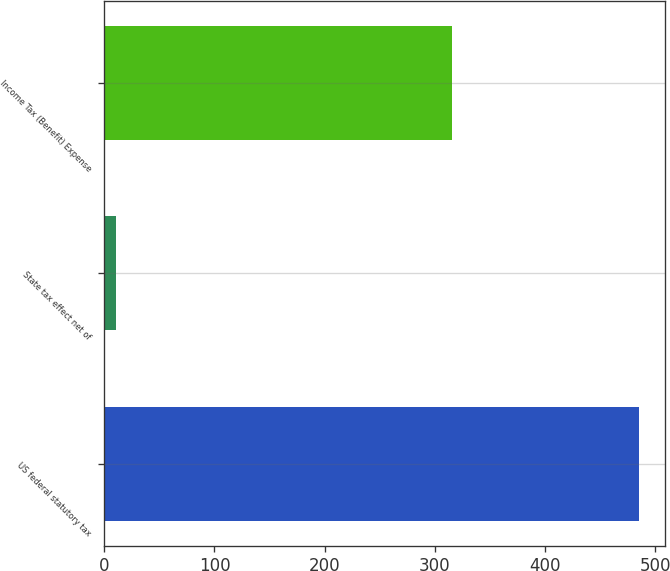<chart> <loc_0><loc_0><loc_500><loc_500><bar_chart><fcel>US federal statutory tax<fcel>State tax effect net of<fcel>Income Tax (Benefit) Expense<nl><fcel>485<fcel>11<fcel>316<nl></chart> 